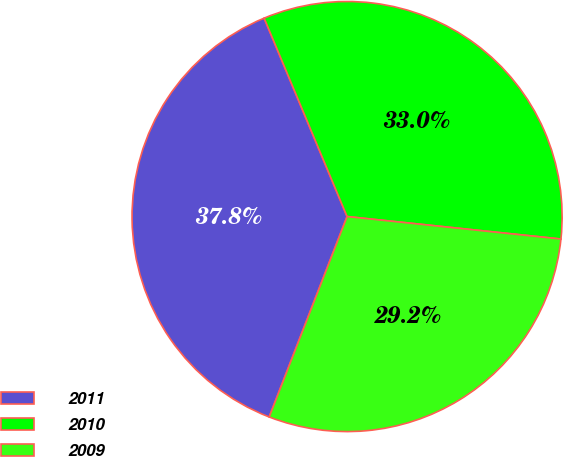<chart> <loc_0><loc_0><loc_500><loc_500><pie_chart><fcel>2011<fcel>2010<fcel>2009<nl><fcel>37.8%<fcel>32.97%<fcel>29.23%<nl></chart> 